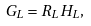<formula> <loc_0><loc_0><loc_500><loc_500>G _ { L } = R _ { L } H _ { L } , \\</formula> 